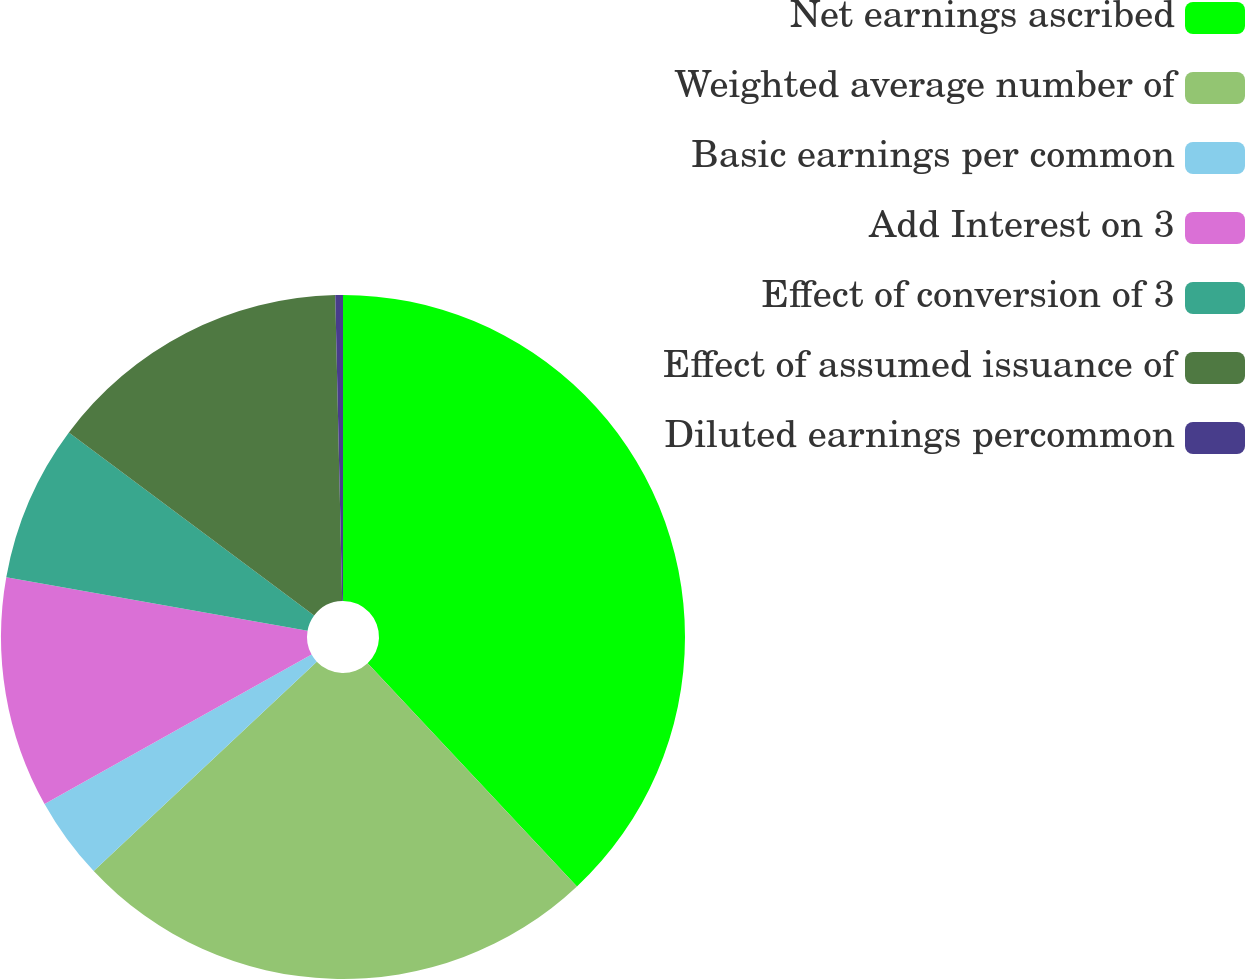Convert chart to OTSL. <chart><loc_0><loc_0><loc_500><loc_500><pie_chart><fcel>Net earnings ascribed<fcel>Weighted average number of<fcel>Basic earnings per common<fcel>Add Interest on 3<fcel>Effect of conversion of 3<fcel>Effect of assumed issuance of<fcel>Diluted earnings percommon<nl><fcel>38.01%<fcel>24.99%<fcel>3.88%<fcel>10.92%<fcel>7.4%<fcel>14.44%<fcel>0.36%<nl></chart> 